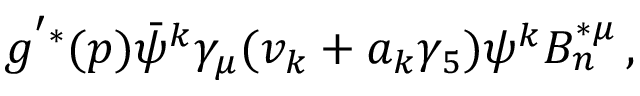<formula> <loc_0><loc_0><loc_500><loc_500>g ^ { ^ { \prime } * } ( p ) \bar { \psi } ^ { k } \gamma _ { \mu } ( v _ { k } + a _ { k } \gamma _ { 5 } ) \psi ^ { k } B _ { n } ^ { * \mu } \, ,</formula> 